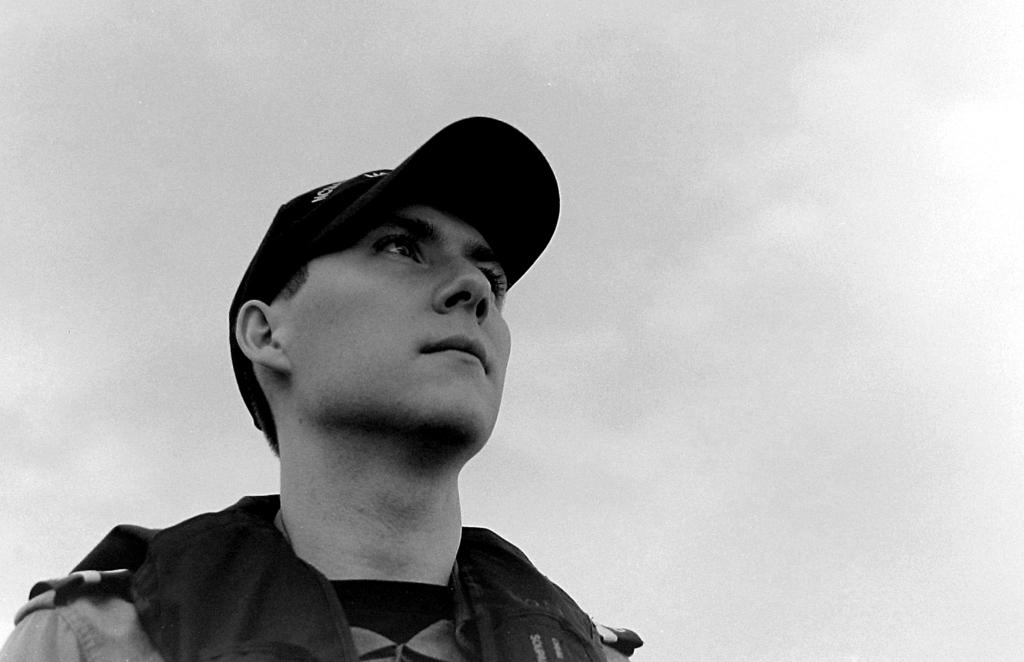Who is present in the image? There is a man in the image. What is the man wearing on his head? The man is wearing a cap on his head. What is the color scheme of the image? The image is in black and white. What can be seen in the background of the image? The sky is visible in the background of the image. How does the cow in the image attract attention? There is no cow present in the image; it only features a man wearing a cap. 